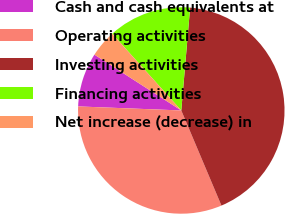Convert chart to OTSL. <chart><loc_0><loc_0><loc_500><loc_500><pie_chart><fcel>Cash and cash equivalents at<fcel>Operating activities<fcel>Investing activities<fcel>Financing activities<fcel>Net increase (decrease) in<nl><fcel>8.47%<fcel>31.98%<fcel>42.28%<fcel>13.03%<fcel>4.24%<nl></chart> 